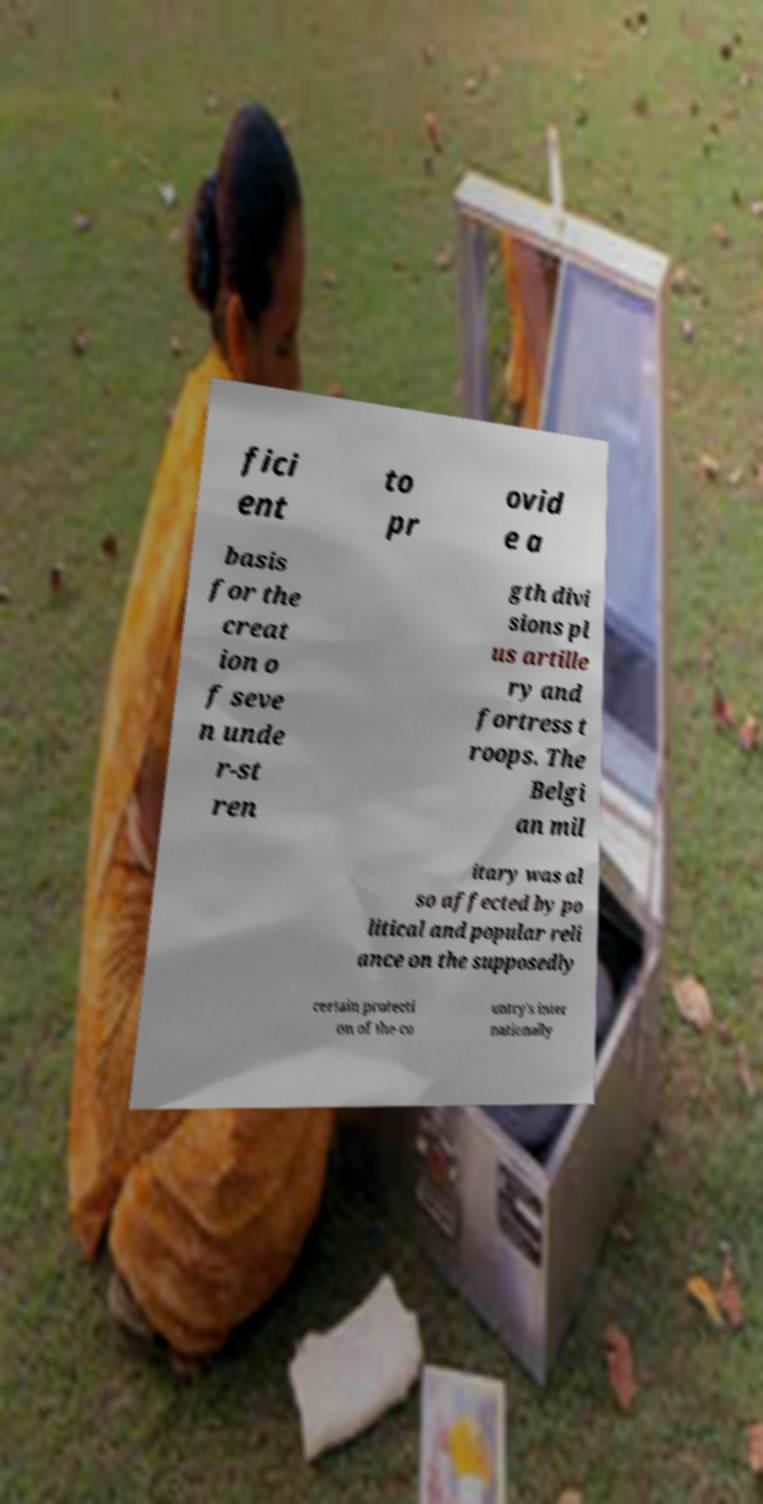For documentation purposes, I need the text within this image transcribed. Could you provide that? fici ent to pr ovid e a basis for the creat ion o f seve n unde r-st ren gth divi sions pl us artille ry and fortress t roops. The Belgi an mil itary was al so affected by po litical and popular reli ance on the supposedly certain protecti on of the co untry's inter nationally 